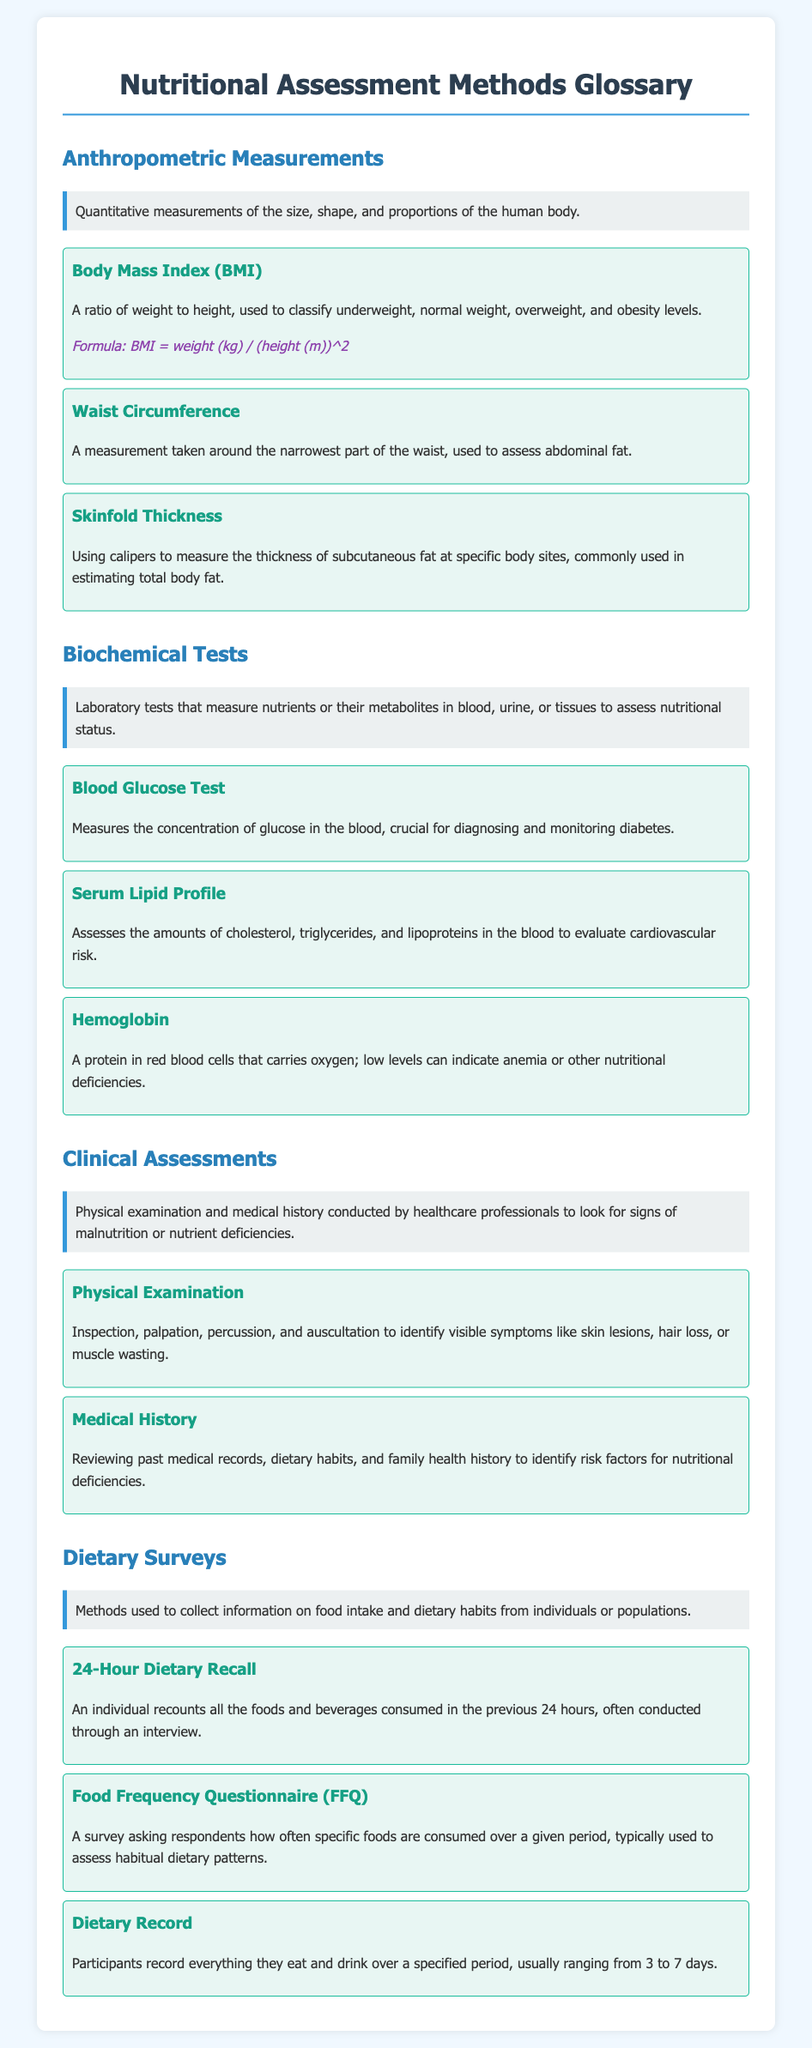What are anthropometric measurements? Anthropometric measurements are quantitative measurements of the size, shape, and proportions of the human body.
Answer: Quantitative measurements What does BMI stand for? BMI is the acronym for Body Mass Index, which is mentioned as an example of anthropometric measurements in the document.
Answer: Body Mass Index What does a blood glucose test measure? The blood glucose test measures the concentration of glucose in the blood.
Answer: Concentration of glucose What is the main purpose of dietary surveys? Dietary surveys are methods used to collect information on food intake and dietary habits.
Answer: Food intake and dietary habits How is skinfold thickness measured? Skinfold thickness is measured using calipers at specific body sites to estimate total body fat.
Answer: Calipers What nutrient does hemoglobin carry? Hemoglobin carries oxygen in red blood cells.
Answer: Oxygen What type of assessment includes physical examination? Clinical assessments include physical examination and medical history.
Answer: Clinical assessments How long does a 24-hour dietary recall assess intake? A 24-hour dietary recall assesses all foods and beverages consumed in the previous 24 hours.
Answer: 24 hours What kind of history is reviewed in clinical assessments? Medical history is reviewed to identify risk factors for nutritional deficiencies.
Answer: Medical history 